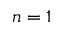Convert formula to latex. <formula><loc_0><loc_0><loc_500><loc_500>n = 1</formula> 